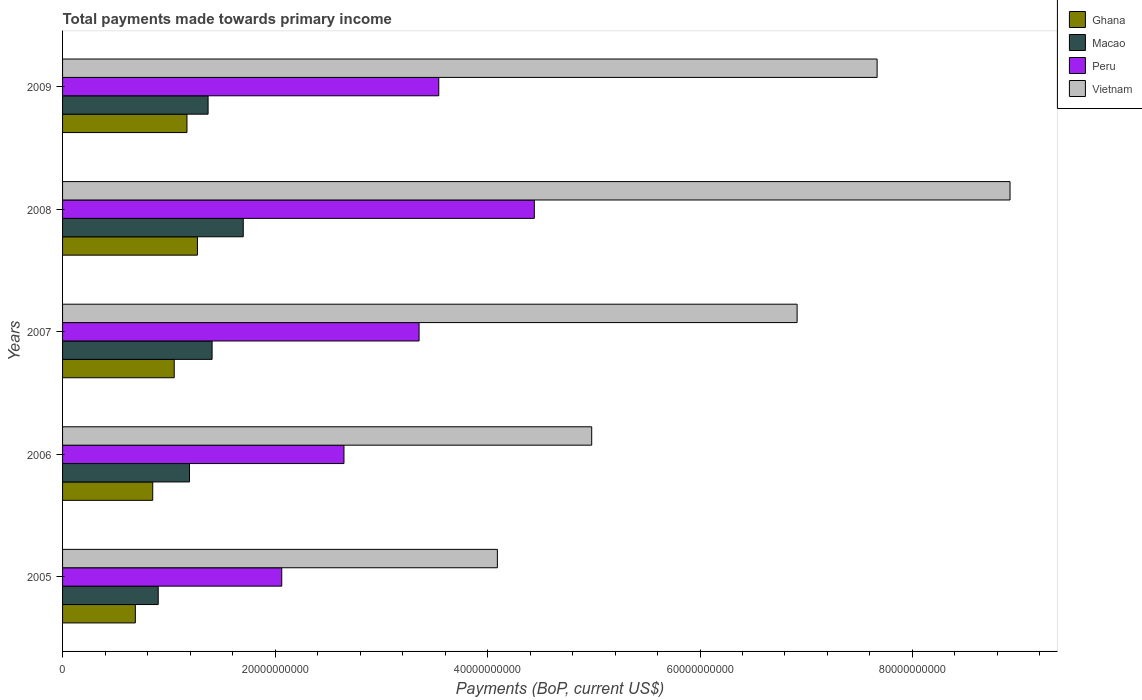How many groups of bars are there?
Your response must be concise. 5. What is the total payments made towards primary income in Macao in 2007?
Your answer should be compact. 1.41e+1. Across all years, what is the maximum total payments made towards primary income in Ghana?
Ensure brevity in your answer.  1.27e+1. Across all years, what is the minimum total payments made towards primary income in Vietnam?
Make the answer very short. 4.09e+1. In which year was the total payments made towards primary income in Vietnam maximum?
Offer a very short reply. 2008. What is the total total payments made towards primary income in Macao in the graph?
Provide a short and direct response. 6.57e+1. What is the difference between the total payments made towards primary income in Macao in 2006 and that in 2009?
Your response must be concise. -1.75e+09. What is the difference between the total payments made towards primary income in Ghana in 2009 and the total payments made towards primary income in Peru in 2008?
Offer a very short reply. -3.27e+1. What is the average total payments made towards primary income in Macao per year?
Provide a short and direct response. 1.31e+1. In the year 2006, what is the difference between the total payments made towards primary income in Vietnam and total payments made towards primary income in Macao?
Make the answer very short. 3.79e+1. In how many years, is the total payments made towards primary income in Vietnam greater than 52000000000 US$?
Your answer should be very brief. 3. What is the ratio of the total payments made towards primary income in Peru in 2008 to that in 2009?
Offer a terse response. 1.25. What is the difference between the highest and the second highest total payments made towards primary income in Peru?
Offer a very short reply. 8.99e+09. What is the difference between the highest and the lowest total payments made towards primary income in Ghana?
Provide a succinct answer. 5.84e+09. In how many years, is the total payments made towards primary income in Peru greater than the average total payments made towards primary income in Peru taken over all years?
Provide a short and direct response. 3. Is the sum of the total payments made towards primary income in Peru in 2005 and 2006 greater than the maximum total payments made towards primary income in Macao across all years?
Ensure brevity in your answer.  Yes. Is it the case that in every year, the sum of the total payments made towards primary income in Ghana and total payments made towards primary income in Vietnam is greater than the sum of total payments made towards primary income in Macao and total payments made towards primary income in Peru?
Give a very brief answer. Yes. What does the 3rd bar from the top in 2009 represents?
Offer a terse response. Macao. How many bars are there?
Your response must be concise. 20. How many years are there in the graph?
Your response must be concise. 5. What is the difference between two consecutive major ticks on the X-axis?
Your response must be concise. 2.00e+1. Are the values on the major ticks of X-axis written in scientific E-notation?
Your answer should be compact. No. Does the graph contain any zero values?
Make the answer very short. No. Does the graph contain grids?
Offer a very short reply. No. How are the legend labels stacked?
Your response must be concise. Vertical. What is the title of the graph?
Offer a terse response. Total payments made towards primary income. Does "Guinea-Bissau" appear as one of the legend labels in the graph?
Offer a terse response. No. What is the label or title of the X-axis?
Ensure brevity in your answer.  Payments (BoP, current US$). What is the label or title of the Y-axis?
Your answer should be very brief. Years. What is the Payments (BoP, current US$) of Ghana in 2005?
Your response must be concise. 6.85e+09. What is the Payments (BoP, current US$) in Macao in 2005?
Offer a very short reply. 9.00e+09. What is the Payments (BoP, current US$) in Peru in 2005?
Provide a short and direct response. 2.06e+1. What is the Payments (BoP, current US$) of Vietnam in 2005?
Your answer should be very brief. 4.09e+1. What is the Payments (BoP, current US$) of Ghana in 2006?
Offer a very short reply. 8.49e+09. What is the Payments (BoP, current US$) of Macao in 2006?
Your answer should be compact. 1.19e+1. What is the Payments (BoP, current US$) in Peru in 2006?
Offer a very short reply. 2.65e+1. What is the Payments (BoP, current US$) in Vietnam in 2006?
Give a very brief answer. 4.98e+1. What is the Payments (BoP, current US$) of Ghana in 2007?
Provide a short and direct response. 1.05e+1. What is the Payments (BoP, current US$) in Macao in 2007?
Ensure brevity in your answer.  1.41e+1. What is the Payments (BoP, current US$) of Peru in 2007?
Make the answer very short. 3.36e+1. What is the Payments (BoP, current US$) in Vietnam in 2007?
Make the answer very short. 6.91e+1. What is the Payments (BoP, current US$) of Ghana in 2008?
Make the answer very short. 1.27e+1. What is the Payments (BoP, current US$) in Macao in 2008?
Your answer should be very brief. 1.70e+1. What is the Payments (BoP, current US$) of Peru in 2008?
Ensure brevity in your answer.  4.44e+1. What is the Payments (BoP, current US$) in Vietnam in 2008?
Offer a very short reply. 8.92e+1. What is the Payments (BoP, current US$) in Ghana in 2009?
Provide a succinct answer. 1.17e+1. What is the Payments (BoP, current US$) in Macao in 2009?
Ensure brevity in your answer.  1.37e+1. What is the Payments (BoP, current US$) in Peru in 2009?
Give a very brief answer. 3.54e+1. What is the Payments (BoP, current US$) of Vietnam in 2009?
Your answer should be very brief. 7.67e+1. Across all years, what is the maximum Payments (BoP, current US$) of Ghana?
Provide a short and direct response. 1.27e+1. Across all years, what is the maximum Payments (BoP, current US$) in Macao?
Give a very brief answer. 1.70e+1. Across all years, what is the maximum Payments (BoP, current US$) of Peru?
Your answer should be very brief. 4.44e+1. Across all years, what is the maximum Payments (BoP, current US$) in Vietnam?
Give a very brief answer. 8.92e+1. Across all years, what is the minimum Payments (BoP, current US$) in Ghana?
Provide a short and direct response. 6.85e+09. Across all years, what is the minimum Payments (BoP, current US$) in Macao?
Give a very brief answer. 9.00e+09. Across all years, what is the minimum Payments (BoP, current US$) in Peru?
Give a very brief answer. 2.06e+1. Across all years, what is the minimum Payments (BoP, current US$) in Vietnam?
Provide a short and direct response. 4.09e+1. What is the total Payments (BoP, current US$) of Ghana in the graph?
Offer a terse response. 5.03e+1. What is the total Payments (BoP, current US$) of Macao in the graph?
Keep it short and to the point. 6.57e+1. What is the total Payments (BoP, current US$) of Peru in the graph?
Your response must be concise. 1.60e+11. What is the total Payments (BoP, current US$) of Vietnam in the graph?
Your response must be concise. 3.26e+11. What is the difference between the Payments (BoP, current US$) in Ghana in 2005 and that in 2006?
Offer a very short reply. -1.64e+09. What is the difference between the Payments (BoP, current US$) of Macao in 2005 and that in 2006?
Make the answer very short. -2.94e+09. What is the difference between the Payments (BoP, current US$) in Peru in 2005 and that in 2006?
Provide a short and direct response. -5.86e+09. What is the difference between the Payments (BoP, current US$) of Vietnam in 2005 and that in 2006?
Offer a very short reply. -8.88e+09. What is the difference between the Payments (BoP, current US$) of Ghana in 2005 and that in 2007?
Keep it short and to the point. -3.66e+09. What is the difference between the Payments (BoP, current US$) of Macao in 2005 and that in 2007?
Your answer should be compact. -5.07e+09. What is the difference between the Payments (BoP, current US$) of Peru in 2005 and that in 2007?
Give a very brief answer. -1.29e+1. What is the difference between the Payments (BoP, current US$) of Vietnam in 2005 and that in 2007?
Provide a succinct answer. -2.82e+1. What is the difference between the Payments (BoP, current US$) in Ghana in 2005 and that in 2008?
Offer a terse response. -5.84e+09. What is the difference between the Payments (BoP, current US$) of Macao in 2005 and that in 2008?
Make the answer very short. -8.00e+09. What is the difference between the Payments (BoP, current US$) of Peru in 2005 and that in 2008?
Offer a very short reply. -2.38e+1. What is the difference between the Payments (BoP, current US$) of Vietnam in 2005 and that in 2008?
Provide a short and direct response. -4.83e+1. What is the difference between the Payments (BoP, current US$) of Ghana in 2005 and that in 2009?
Your answer should be compact. -4.86e+09. What is the difference between the Payments (BoP, current US$) in Macao in 2005 and that in 2009?
Provide a succinct answer. -4.69e+09. What is the difference between the Payments (BoP, current US$) of Peru in 2005 and that in 2009?
Provide a succinct answer. -1.48e+1. What is the difference between the Payments (BoP, current US$) in Vietnam in 2005 and that in 2009?
Provide a short and direct response. -3.57e+1. What is the difference between the Payments (BoP, current US$) of Ghana in 2006 and that in 2007?
Your response must be concise. -2.02e+09. What is the difference between the Payments (BoP, current US$) of Macao in 2006 and that in 2007?
Your answer should be compact. -2.13e+09. What is the difference between the Payments (BoP, current US$) in Peru in 2006 and that in 2007?
Provide a succinct answer. -7.07e+09. What is the difference between the Payments (BoP, current US$) of Vietnam in 2006 and that in 2007?
Give a very brief answer. -1.93e+1. What is the difference between the Payments (BoP, current US$) of Ghana in 2006 and that in 2008?
Offer a terse response. -4.21e+09. What is the difference between the Payments (BoP, current US$) of Macao in 2006 and that in 2008?
Provide a short and direct response. -5.06e+09. What is the difference between the Payments (BoP, current US$) of Peru in 2006 and that in 2008?
Offer a terse response. -1.79e+1. What is the difference between the Payments (BoP, current US$) in Vietnam in 2006 and that in 2008?
Make the answer very short. -3.94e+1. What is the difference between the Payments (BoP, current US$) in Ghana in 2006 and that in 2009?
Provide a short and direct response. -3.22e+09. What is the difference between the Payments (BoP, current US$) in Macao in 2006 and that in 2009?
Provide a succinct answer. -1.75e+09. What is the difference between the Payments (BoP, current US$) of Peru in 2006 and that in 2009?
Give a very brief answer. -8.92e+09. What is the difference between the Payments (BoP, current US$) of Vietnam in 2006 and that in 2009?
Your answer should be compact. -2.69e+1. What is the difference between the Payments (BoP, current US$) of Ghana in 2007 and that in 2008?
Keep it short and to the point. -2.19e+09. What is the difference between the Payments (BoP, current US$) in Macao in 2007 and that in 2008?
Give a very brief answer. -2.93e+09. What is the difference between the Payments (BoP, current US$) of Peru in 2007 and that in 2008?
Offer a very short reply. -1.08e+1. What is the difference between the Payments (BoP, current US$) of Vietnam in 2007 and that in 2008?
Ensure brevity in your answer.  -2.00e+1. What is the difference between the Payments (BoP, current US$) in Ghana in 2007 and that in 2009?
Make the answer very short. -1.20e+09. What is the difference between the Payments (BoP, current US$) in Macao in 2007 and that in 2009?
Your response must be concise. 3.76e+08. What is the difference between the Payments (BoP, current US$) in Peru in 2007 and that in 2009?
Make the answer very short. -1.85e+09. What is the difference between the Payments (BoP, current US$) of Vietnam in 2007 and that in 2009?
Provide a succinct answer. -7.53e+09. What is the difference between the Payments (BoP, current US$) of Ghana in 2008 and that in 2009?
Give a very brief answer. 9.85e+08. What is the difference between the Payments (BoP, current US$) of Macao in 2008 and that in 2009?
Your answer should be compact. 3.31e+09. What is the difference between the Payments (BoP, current US$) of Peru in 2008 and that in 2009?
Provide a short and direct response. 8.99e+09. What is the difference between the Payments (BoP, current US$) of Vietnam in 2008 and that in 2009?
Your answer should be compact. 1.25e+1. What is the difference between the Payments (BoP, current US$) of Ghana in 2005 and the Payments (BoP, current US$) of Macao in 2006?
Offer a very short reply. -5.10e+09. What is the difference between the Payments (BoP, current US$) in Ghana in 2005 and the Payments (BoP, current US$) in Peru in 2006?
Provide a succinct answer. -1.96e+1. What is the difference between the Payments (BoP, current US$) in Ghana in 2005 and the Payments (BoP, current US$) in Vietnam in 2006?
Your answer should be compact. -4.30e+1. What is the difference between the Payments (BoP, current US$) of Macao in 2005 and the Payments (BoP, current US$) of Peru in 2006?
Provide a short and direct response. -1.75e+1. What is the difference between the Payments (BoP, current US$) in Macao in 2005 and the Payments (BoP, current US$) in Vietnam in 2006?
Ensure brevity in your answer.  -4.08e+1. What is the difference between the Payments (BoP, current US$) of Peru in 2005 and the Payments (BoP, current US$) of Vietnam in 2006?
Offer a terse response. -2.92e+1. What is the difference between the Payments (BoP, current US$) in Ghana in 2005 and the Payments (BoP, current US$) in Macao in 2007?
Your answer should be compact. -7.22e+09. What is the difference between the Payments (BoP, current US$) in Ghana in 2005 and the Payments (BoP, current US$) in Peru in 2007?
Offer a very short reply. -2.67e+1. What is the difference between the Payments (BoP, current US$) in Ghana in 2005 and the Payments (BoP, current US$) in Vietnam in 2007?
Your answer should be compact. -6.23e+1. What is the difference between the Payments (BoP, current US$) of Macao in 2005 and the Payments (BoP, current US$) of Peru in 2007?
Make the answer very short. -2.46e+1. What is the difference between the Payments (BoP, current US$) in Macao in 2005 and the Payments (BoP, current US$) in Vietnam in 2007?
Make the answer very short. -6.01e+1. What is the difference between the Payments (BoP, current US$) in Peru in 2005 and the Payments (BoP, current US$) in Vietnam in 2007?
Make the answer very short. -4.85e+1. What is the difference between the Payments (BoP, current US$) of Ghana in 2005 and the Payments (BoP, current US$) of Macao in 2008?
Ensure brevity in your answer.  -1.02e+1. What is the difference between the Payments (BoP, current US$) of Ghana in 2005 and the Payments (BoP, current US$) of Peru in 2008?
Your answer should be very brief. -3.76e+1. What is the difference between the Payments (BoP, current US$) of Ghana in 2005 and the Payments (BoP, current US$) of Vietnam in 2008?
Offer a terse response. -8.23e+1. What is the difference between the Payments (BoP, current US$) of Macao in 2005 and the Payments (BoP, current US$) of Peru in 2008?
Keep it short and to the point. -3.54e+1. What is the difference between the Payments (BoP, current US$) of Macao in 2005 and the Payments (BoP, current US$) of Vietnam in 2008?
Keep it short and to the point. -8.02e+1. What is the difference between the Payments (BoP, current US$) in Peru in 2005 and the Payments (BoP, current US$) in Vietnam in 2008?
Provide a succinct answer. -6.86e+1. What is the difference between the Payments (BoP, current US$) in Ghana in 2005 and the Payments (BoP, current US$) in Macao in 2009?
Keep it short and to the point. -6.85e+09. What is the difference between the Payments (BoP, current US$) in Ghana in 2005 and the Payments (BoP, current US$) in Peru in 2009?
Give a very brief answer. -2.86e+1. What is the difference between the Payments (BoP, current US$) of Ghana in 2005 and the Payments (BoP, current US$) of Vietnam in 2009?
Keep it short and to the point. -6.98e+1. What is the difference between the Payments (BoP, current US$) in Macao in 2005 and the Payments (BoP, current US$) in Peru in 2009?
Offer a terse response. -2.64e+1. What is the difference between the Payments (BoP, current US$) in Macao in 2005 and the Payments (BoP, current US$) in Vietnam in 2009?
Offer a very short reply. -6.77e+1. What is the difference between the Payments (BoP, current US$) of Peru in 2005 and the Payments (BoP, current US$) of Vietnam in 2009?
Provide a succinct answer. -5.60e+1. What is the difference between the Payments (BoP, current US$) of Ghana in 2006 and the Payments (BoP, current US$) of Macao in 2007?
Your response must be concise. -5.59e+09. What is the difference between the Payments (BoP, current US$) of Ghana in 2006 and the Payments (BoP, current US$) of Peru in 2007?
Provide a short and direct response. -2.51e+1. What is the difference between the Payments (BoP, current US$) in Ghana in 2006 and the Payments (BoP, current US$) in Vietnam in 2007?
Provide a succinct answer. -6.07e+1. What is the difference between the Payments (BoP, current US$) of Macao in 2006 and the Payments (BoP, current US$) of Peru in 2007?
Provide a short and direct response. -2.16e+1. What is the difference between the Payments (BoP, current US$) in Macao in 2006 and the Payments (BoP, current US$) in Vietnam in 2007?
Give a very brief answer. -5.72e+1. What is the difference between the Payments (BoP, current US$) of Peru in 2006 and the Payments (BoP, current US$) of Vietnam in 2007?
Provide a succinct answer. -4.27e+1. What is the difference between the Payments (BoP, current US$) of Ghana in 2006 and the Payments (BoP, current US$) of Macao in 2008?
Make the answer very short. -8.52e+09. What is the difference between the Payments (BoP, current US$) of Ghana in 2006 and the Payments (BoP, current US$) of Peru in 2008?
Keep it short and to the point. -3.59e+1. What is the difference between the Payments (BoP, current US$) in Ghana in 2006 and the Payments (BoP, current US$) in Vietnam in 2008?
Make the answer very short. -8.07e+1. What is the difference between the Payments (BoP, current US$) of Macao in 2006 and the Payments (BoP, current US$) of Peru in 2008?
Give a very brief answer. -3.25e+1. What is the difference between the Payments (BoP, current US$) in Macao in 2006 and the Payments (BoP, current US$) in Vietnam in 2008?
Your response must be concise. -7.72e+1. What is the difference between the Payments (BoP, current US$) in Peru in 2006 and the Payments (BoP, current US$) in Vietnam in 2008?
Offer a very short reply. -6.27e+1. What is the difference between the Payments (BoP, current US$) in Ghana in 2006 and the Payments (BoP, current US$) in Macao in 2009?
Provide a short and direct response. -5.21e+09. What is the difference between the Payments (BoP, current US$) of Ghana in 2006 and the Payments (BoP, current US$) of Peru in 2009?
Make the answer very short. -2.69e+1. What is the difference between the Payments (BoP, current US$) in Ghana in 2006 and the Payments (BoP, current US$) in Vietnam in 2009?
Make the answer very short. -6.82e+1. What is the difference between the Payments (BoP, current US$) of Macao in 2006 and the Payments (BoP, current US$) of Peru in 2009?
Offer a very short reply. -2.35e+1. What is the difference between the Payments (BoP, current US$) in Macao in 2006 and the Payments (BoP, current US$) in Vietnam in 2009?
Ensure brevity in your answer.  -6.47e+1. What is the difference between the Payments (BoP, current US$) in Peru in 2006 and the Payments (BoP, current US$) in Vietnam in 2009?
Offer a terse response. -5.02e+1. What is the difference between the Payments (BoP, current US$) of Ghana in 2007 and the Payments (BoP, current US$) of Macao in 2008?
Your answer should be very brief. -6.50e+09. What is the difference between the Payments (BoP, current US$) of Ghana in 2007 and the Payments (BoP, current US$) of Peru in 2008?
Your answer should be compact. -3.39e+1. What is the difference between the Payments (BoP, current US$) in Ghana in 2007 and the Payments (BoP, current US$) in Vietnam in 2008?
Your answer should be very brief. -7.87e+1. What is the difference between the Payments (BoP, current US$) of Macao in 2007 and the Payments (BoP, current US$) of Peru in 2008?
Make the answer very short. -3.03e+1. What is the difference between the Payments (BoP, current US$) of Macao in 2007 and the Payments (BoP, current US$) of Vietnam in 2008?
Your answer should be very brief. -7.51e+1. What is the difference between the Payments (BoP, current US$) in Peru in 2007 and the Payments (BoP, current US$) in Vietnam in 2008?
Keep it short and to the point. -5.56e+1. What is the difference between the Payments (BoP, current US$) of Ghana in 2007 and the Payments (BoP, current US$) of Macao in 2009?
Your answer should be compact. -3.19e+09. What is the difference between the Payments (BoP, current US$) in Ghana in 2007 and the Payments (BoP, current US$) in Peru in 2009?
Keep it short and to the point. -2.49e+1. What is the difference between the Payments (BoP, current US$) of Ghana in 2007 and the Payments (BoP, current US$) of Vietnam in 2009?
Offer a terse response. -6.62e+1. What is the difference between the Payments (BoP, current US$) in Macao in 2007 and the Payments (BoP, current US$) in Peru in 2009?
Your answer should be very brief. -2.13e+1. What is the difference between the Payments (BoP, current US$) of Macao in 2007 and the Payments (BoP, current US$) of Vietnam in 2009?
Offer a very short reply. -6.26e+1. What is the difference between the Payments (BoP, current US$) in Peru in 2007 and the Payments (BoP, current US$) in Vietnam in 2009?
Give a very brief answer. -4.31e+1. What is the difference between the Payments (BoP, current US$) in Ghana in 2008 and the Payments (BoP, current US$) in Macao in 2009?
Your answer should be compact. -1.00e+09. What is the difference between the Payments (BoP, current US$) of Ghana in 2008 and the Payments (BoP, current US$) of Peru in 2009?
Provide a succinct answer. -2.27e+1. What is the difference between the Payments (BoP, current US$) in Ghana in 2008 and the Payments (BoP, current US$) in Vietnam in 2009?
Offer a terse response. -6.40e+1. What is the difference between the Payments (BoP, current US$) in Macao in 2008 and the Payments (BoP, current US$) in Peru in 2009?
Your answer should be very brief. -1.84e+1. What is the difference between the Payments (BoP, current US$) in Macao in 2008 and the Payments (BoP, current US$) in Vietnam in 2009?
Offer a terse response. -5.97e+1. What is the difference between the Payments (BoP, current US$) in Peru in 2008 and the Payments (BoP, current US$) in Vietnam in 2009?
Your answer should be very brief. -3.23e+1. What is the average Payments (BoP, current US$) in Ghana per year?
Ensure brevity in your answer.  1.01e+1. What is the average Payments (BoP, current US$) of Macao per year?
Your response must be concise. 1.31e+1. What is the average Payments (BoP, current US$) in Peru per year?
Provide a short and direct response. 3.21e+1. What is the average Payments (BoP, current US$) of Vietnam per year?
Make the answer very short. 6.51e+1. In the year 2005, what is the difference between the Payments (BoP, current US$) of Ghana and Payments (BoP, current US$) of Macao?
Your answer should be very brief. -2.15e+09. In the year 2005, what is the difference between the Payments (BoP, current US$) of Ghana and Payments (BoP, current US$) of Peru?
Give a very brief answer. -1.38e+1. In the year 2005, what is the difference between the Payments (BoP, current US$) of Ghana and Payments (BoP, current US$) of Vietnam?
Your response must be concise. -3.41e+1. In the year 2005, what is the difference between the Payments (BoP, current US$) in Macao and Payments (BoP, current US$) in Peru?
Your answer should be compact. -1.16e+1. In the year 2005, what is the difference between the Payments (BoP, current US$) in Macao and Payments (BoP, current US$) in Vietnam?
Your answer should be compact. -3.19e+1. In the year 2005, what is the difference between the Payments (BoP, current US$) of Peru and Payments (BoP, current US$) of Vietnam?
Your answer should be compact. -2.03e+1. In the year 2006, what is the difference between the Payments (BoP, current US$) of Ghana and Payments (BoP, current US$) of Macao?
Offer a terse response. -3.46e+09. In the year 2006, what is the difference between the Payments (BoP, current US$) in Ghana and Payments (BoP, current US$) in Peru?
Your response must be concise. -1.80e+1. In the year 2006, what is the difference between the Payments (BoP, current US$) of Ghana and Payments (BoP, current US$) of Vietnam?
Give a very brief answer. -4.13e+1. In the year 2006, what is the difference between the Payments (BoP, current US$) in Macao and Payments (BoP, current US$) in Peru?
Your answer should be very brief. -1.45e+1. In the year 2006, what is the difference between the Payments (BoP, current US$) in Macao and Payments (BoP, current US$) in Vietnam?
Your answer should be compact. -3.79e+1. In the year 2006, what is the difference between the Payments (BoP, current US$) in Peru and Payments (BoP, current US$) in Vietnam?
Your answer should be very brief. -2.33e+1. In the year 2007, what is the difference between the Payments (BoP, current US$) in Ghana and Payments (BoP, current US$) in Macao?
Your answer should be compact. -3.56e+09. In the year 2007, what is the difference between the Payments (BoP, current US$) in Ghana and Payments (BoP, current US$) in Peru?
Your response must be concise. -2.30e+1. In the year 2007, what is the difference between the Payments (BoP, current US$) of Ghana and Payments (BoP, current US$) of Vietnam?
Offer a terse response. -5.86e+1. In the year 2007, what is the difference between the Payments (BoP, current US$) of Macao and Payments (BoP, current US$) of Peru?
Make the answer very short. -1.95e+1. In the year 2007, what is the difference between the Payments (BoP, current US$) of Macao and Payments (BoP, current US$) of Vietnam?
Give a very brief answer. -5.51e+1. In the year 2007, what is the difference between the Payments (BoP, current US$) in Peru and Payments (BoP, current US$) in Vietnam?
Your answer should be very brief. -3.56e+1. In the year 2008, what is the difference between the Payments (BoP, current US$) of Ghana and Payments (BoP, current US$) of Macao?
Offer a very short reply. -4.31e+09. In the year 2008, what is the difference between the Payments (BoP, current US$) in Ghana and Payments (BoP, current US$) in Peru?
Ensure brevity in your answer.  -3.17e+1. In the year 2008, what is the difference between the Payments (BoP, current US$) of Ghana and Payments (BoP, current US$) of Vietnam?
Offer a very short reply. -7.65e+1. In the year 2008, what is the difference between the Payments (BoP, current US$) in Macao and Payments (BoP, current US$) in Peru?
Provide a short and direct response. -2.74e+1. In the year 2008, what is the difference between the Payments (BoP, current US$) of Macao and Payments (BoP, current US$) of Vietnam?
Give a very brief answer. -7.22e+1. In the year 2008, what is the difference between the Payments (BoP, current US$) of Peru and Payments (BoP, current US$) of Vietnam?
Offer a terse response. -4.48e+1. In the year 2009, what is the difference between the Payments (BoP, current US$) in Ghana and Payments (BoP, current US$) in Macao?
Your response must be concise. -1.99e+09. In the year 2009, what is the difference between the Payments (BoP, current US$) of Ghana and Payments (BoP, current US$) of Peru?
Make the answer very short. -2.37e+1. In the year 2009, what is the difference between the Payments (BoP, current US$) of Ghana and Payments (BoP, current US$) of Vietnam?
Ensure brevity in your answer.  -6.50e+1. In the year 2009, what is the difference between the Payments (BoP, current US$) in Macao and Payments (BoP, current US$) in Peru?
Ensure brevity in your answer.  -2.17e+1. In the year 2009, what is the difference between the Payments (BoP, current US$) in Macao and Payments (BoP, current US$) in Vietnam?
Offer a terse response. -6.30e+1. In the year 2009, what is the difference between the Payments (BoP, current US$) in Peru and Payments (BoP, current US$) in Vietnam?
Give a very brief answer. -4.13e+1. What is the ratio of the Payments (BoP, current US$) of Ghana in 2005 to that in 2006?
Your answer should be very brief. 0.81. What is the ratio of the Payments (BoP, current US$) of Macao in 2005 to that in 2006?
Provide a short and direct response. 0.75. What is the ratio of the Payments (BoP, current US$) of Peru in 2005 to that in 2006?
Offer a very short reply. 0.78. What is the ratio of the Payments (BoP, current US$) of Vietnam in 2005 to that in 2006?
Provide a short and direct response. 0.82. What is the ratio of the Payments (BoP, current US$) in Ghana in 2005 to that in 2007?
Offer a terse response. 0.65. What is the ratio of the Payments (BoP, current US$) in Macao in 2005 to that in 2007?
Offer a very short reply. 0.64. What is the ratio of the Payments (BoP, current US$) in Peru in 2005 to that in 2007?
Ensure brevity in your answer.  0.61. What is the ratio of the Payments (BoP, current US$) in Vietnam in 2005 to that in 2007?
Give a very brief answer. 0.59. What is the ratio of the Payments (BoP, current US$) of Ghana in 2005 to that in 2008?
Offer a very short reply. 0.54. What is the ratio of the Payments (BoP, current US$) of Macao in 2005 to that in 2008?
Ensure brevity in your answer.  0.53. What is the ratio of the Payments (BoP, current US$) of Peru in 2005 to that in 2008?
Your answer should be compact. 0.46. What is the ratio of the Payments (BoP, current US$) of Vietnam in 2005 to that in 2008?
Give a very brief answer. 0.46. What is the ratio of the Payments (BoP, current US$) of Ghana in 2005 to that in 2009?
Provide a succinct answer. 0.58. What is the ratio of the Payments (BoP, current US$) in Macao in 2005 to that in 2009?
Offer a terse response. 0.66. What is the ratio of the Payments (BoP, current US$) in Peru in 2005 to that in 2009?
Your response must be concise. 0.58. What is the ratio of the Payments (BoP, current US$) in Vietnam in 2005 to that in 2009?
Provide a short and direct response. 0.53. What is the ratio of the Payments (BoP, current US$) in Ghana in 2006 to that in 2007?
Your response must be concise. 0.81. What is the ratio of the Payments (BoP, current US$) in Macao in 2006 to that in 2007?
Offer a terse response. 0.85. What is the ratio of the Payments (BoP, current US$) in Peru in 2006 to that in 2007?
Your answer should be compact. 0.79. What is the ratio of the Payments (BoP, current US$) in Vietnam in 2006 to that in 2007?
Ensure brevity in your answer.  0.72. What is the ratio of the Payments (BoP, current US$) of Ghana in 2006 to that in 2008?
Give a very brief answer. 0.67. What is the ratio of the Payments (BoP, current US$) of Macao in 2006 to that in 2008?
Give a very brief answer. 0.7. What is the ratio of the Payments (BoP, current US$) of Peru in 2006 to that in 2008?
Provide a succinct answer. 0.6. What is the ratio of the Payments (BoP, current US$) of Vietnam in 2006 to that in 2008?
Offer a terse response. 0.56. What is the ratio of the Payments (BoP, current US$) in Ghana in 2006 to that in 2009?
Ensure brevity in your answer.  0.72. What is the ratio of the Payments (BoP, current US$) of Macao in 2006 to that in 2009?
Make the answer very short. 0.87. What is the ratio of the Payments (BoP, current US$) of Peru in 2006 to that in 2009?
Offer a terse response. 0.75. What is the ratio of the Payments (BoP, current US$) in Vietnam in 2006 to that in 2009?
Ensure brevity in your answer.  0.65. What is the ratio of the Payments (BoP, current US$) in Ghana in 2007 to that in 2008?
Keep it short and to the point. 0.83. What is the ratio of the Payments (BoP, current US$) of Macao in 2007 to that in 2008?
Your response must be concise. 0.83. What is the ratio of the Payments (BoP, current US$) of Peru in 2007 to that in 2008?
Offer a terse response. 0.76. What is the ratio of the Payments (BoP, current US$) in Vietnam in 2007 to that in 2008?
Your answer should be compact. 0.78. What is the ratio of the Payments (BoP, current US$) of Ghana in 2007 to that in 2009?
Keep it short and to the point. 0.9. What is the ratio of the Payments (BoP, current US$) of Macao in 2007 to that in 2009?
Your answer should be compact. 1.03. What is the ratio of the Payments (BoP, current US$) of Peru in 2007 to that in 2009?
Keep it short and to the point. 0.95. What is the ratio of the Payments (BoP, current US$) of Vietnam in 2007 to that in 2009?
Ensure brevity in your answer.  0.9. What is the ratio of the Payments (BoP, current US$) in Ghana in 2008 to that in 2009?
Give a very brief answer. 1.08. What is the ratio of the Payments (BoP, current US$) in Macao in 2008 to that in 2009?
Make the answer very short. 1.24. What is the ratio of the Payments (BoP, current US$) in Peru in 2008 to that in 2009?
Your response must be concise. 1.25. What is the ratio of the Payments (BoP, current US$) of Vietnam in 2008 to that in 2009?
Make the answer very short. 1.16. What is the difference between the highest and the second highest Payments (BoP, current US$) of Ghana?
Provide a succinct answer. 9.85e+08. What is the difference between the highest and the second highest Payments (BoP, current US$) in Macao?
Make the answer very short. 2.93e+09. What is the difference between the highest and the second highest Payments (BoP, current US$) in Peru?
Keep it short and to the point. 8.99e+09. What is the difference between the highest and the second highest Payments (BoP, current US$) in Vietnam?
Provide a succinct answer. 1.25e+1. What is the difference between the highest and the lowest Payments (BoP, current US$) in Ghana?
Your answer should be very brief. 5.84e+09. What is the difference between the highest and the lowest Payments (BoP, current US$) in Macao?
Provide a succinct answer. 8.00e+09. What is the difference between the highest and the lowest Payments (BoP, current US$) in Peru?
Your answer should be very brief. 2.38e+1. What is the difference between the highest and the lowest Payments (BoP, current US$) in Vietnam?
Offer a very short reply. 4.83e+1. 